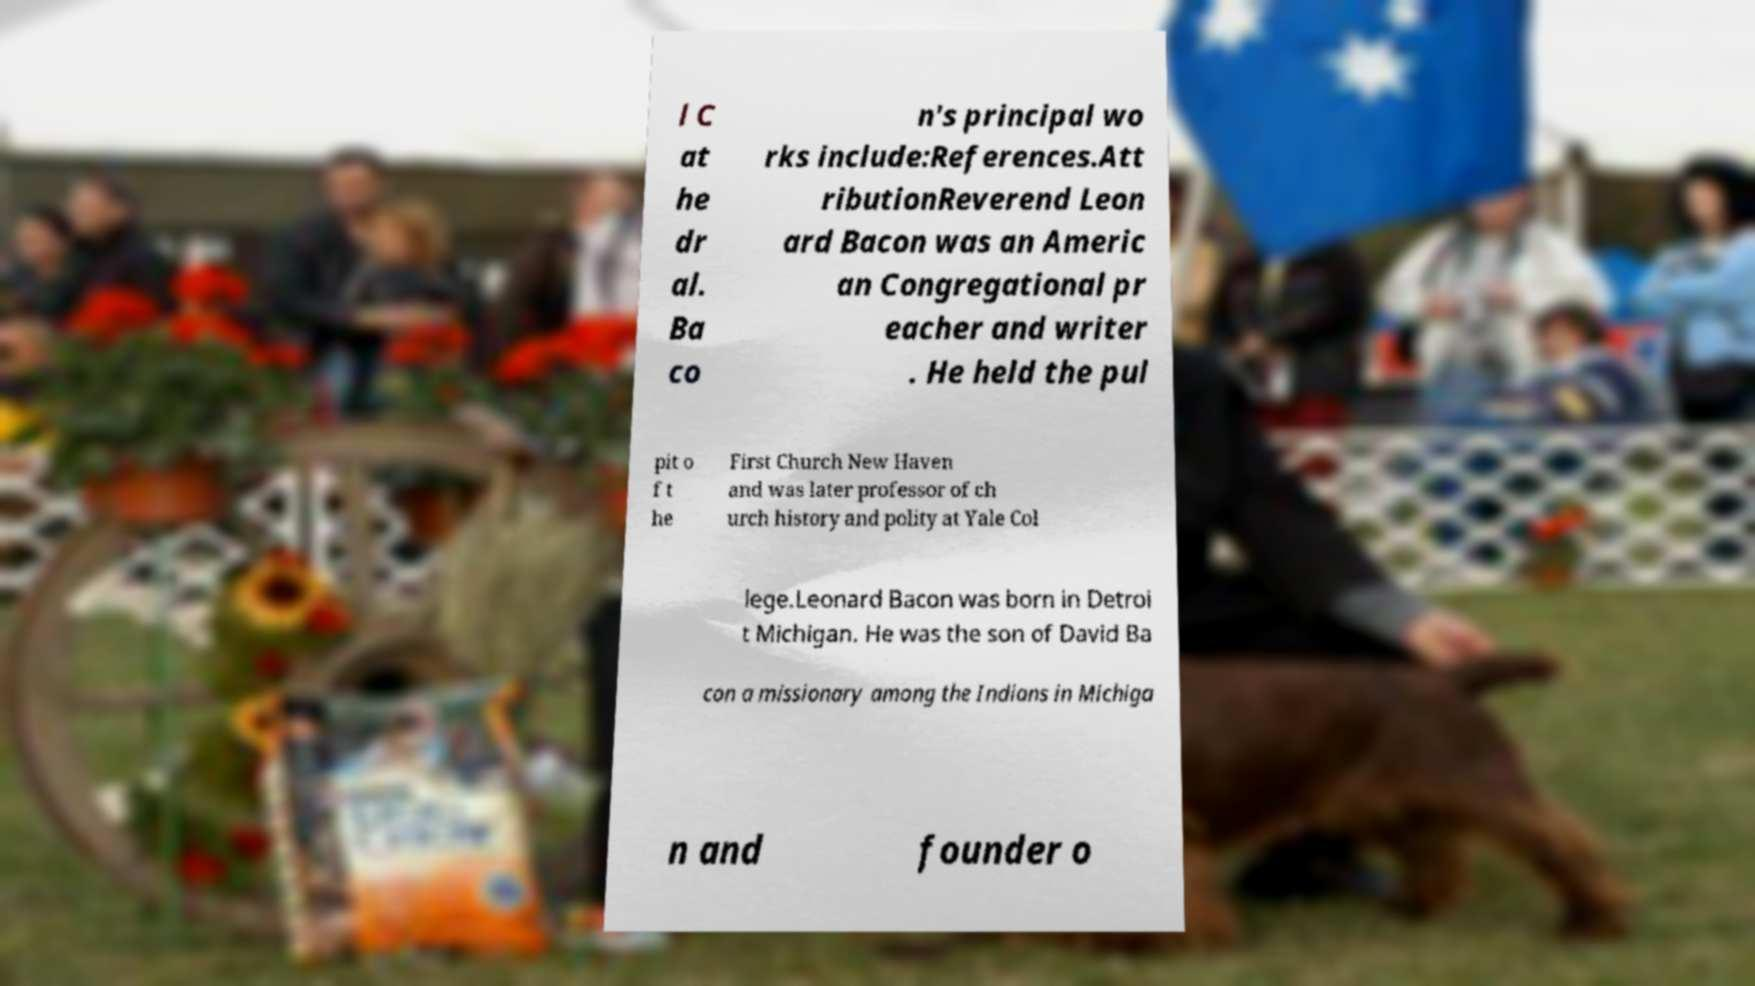Can you read and provide the text displayed in the image?This photo seems to have some interesting text. Can you extract and type it out for me? l C at he dr al. Ba co n's principal wo rks include:References.Att ributionReverend Leon ard Bacon was an Americ an Congregational pr eacher and writer . He held the pul pit o f t he First Church New Haven and was later professor of ch urch history and polity at Yale Col lege.Leonard Bacon was born in Detroi t Michigan. He was the son of David Ba con a missionary among the Indians in Michiga n and founder o 